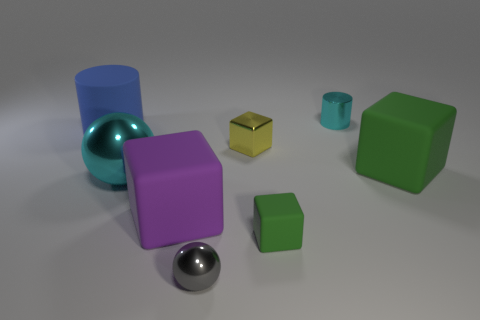Subtract all tiny metallic cubes. How many cubes are left? 3 Add 1 yellow metal things. How many objects exist? 9 Subtract all cyan cylinders. How many cylinders are left? 1 Subtract all spheres. How many objects are left? 6 Subtract 1 cyan spheres. How many objects are left? 7 Subtract 1 cylinders. How many cylinders are left? 1 Subtract all gray blocks. Subtract all cyan spheres. How many blocks are left? 4 Subtract all purple spheres. How many cyan cylinders are left? 1 Subtract all big purple blocks. Subtract all tiny yellow cubes. How many objects are left? 6 Add 2 large things. How many large things are left? 6 